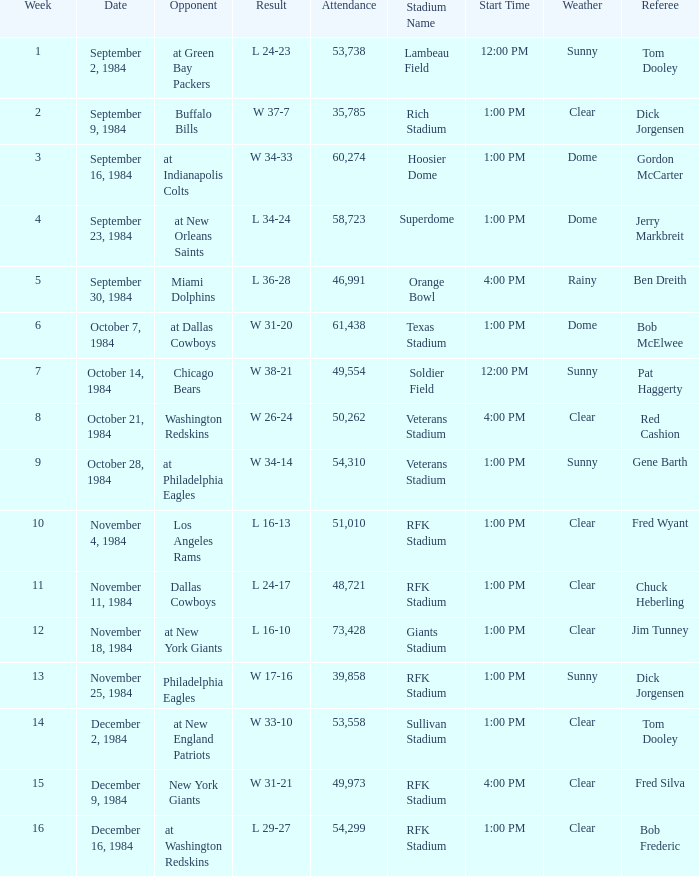What was the result in a week lower than 10 with an opponent of Chicago Bears? W 38-21. Would you be able to parse every entry in this table? {'header': ['Week', 'Date', 'Opponent', 'Result', 'Attendance', 'Stadium Name', 'Start Time', 'Weather', 'Referee'], 'rows': [['1', 'September 2, 1984', 'at Green Bay Packers', 'L 24-23', '53,738', 'Lambeau Field', '12:00 PM', 'Sunny', 'Tom Dooley'], ['2', 'September 9, 1984', 'Buffalo Bills', 'W 37-7', '35,785', 'Rich Stadium', '1:00 PM', 'Clear', 'Dick Jorgensen'], ['3', 'September 16, 1984', 'at Indianapolis Colts', 'W 34-33', '60,274', 'Hoosier Dome', '1:00 PM', 'Dome', 'Gordon McCarter'], ['4', 'September 23, 1984', 'at New Orleans Saints', 'L 34-24', '58,723', 'Superdome', '1:00 PM', 'Dome', 'Jerry Markbreit'], ['5', 'September 30, 1984', 'Miami Dolphins', 'L 36-28', '46,991', 'Orange Bowl', '4:00 PM', 'Rainy', 'Ben Dreith'], ['6', 'October 7, 1984', 'at Dallas Cowboys', 'W 31-20', '61,438', 'Texas Stadium', '1:00 PM', 'Dome', 'Bob McElwee'], ['7', 'October 14, 1984', 'Chicago Bears', 'W 38-21', '49,554', 'Soldier Field', '12:00 PM', 'Sunny', 'Pat Haggerty'], ['8', 'October 21, 1984', 'Washington Redskins', 'W 26-24', '50,262', 'Veterans Stadium', '4:00 PM', 'Clear', 'Red Cashion'], ['9', 'October 28, 1984', 'at Philadelphia Eagles', 'W 34-14', '54,310', 'Veterans Stadium', '1:00 PM', 'Sunny', 'Gene Barth'], ['10', 'November 4, 1984', 'Los Angeles Rams', 'L 16-13', '51,010', 'RFK Stadium', '1:00 PM', 'Clear', 'Fred Wyant'], ['11', 'November 11, 1984', 'Dallas Cowboys', 'L 24-17', '48,721', 'RFK Stadium', '1:00 PM', 'Clear', 'Chuck Heberling'], ['12', 'November 18, 1984', 'at New York Giants', 'L 16-10', '73,428', 'Giants Stadium', '1:00 PM', 'Clear', 'Jim Tunney'], ['13', 'November 25, 1984', 'Philadelphia Eagles', 'W 17-16', '39,858', 'RFK Stadium', '1:00 PM', 'Sunny', 'Dick Jorgensen'], ['14', 'December 2, 1984', 'at New England Patriots', 'W 33-10', '53,558', 'Sullivan Stadium', '1:00 PM', 'Clear', 'Tom Dooley'], ['15', 'December 9, 1984', 'New York Giants', 'W 31-21', '49,973', 'RFK Stadium', '4:00 PM', 'Clear', 'Fred Silva'], ['16', 'December 16, 1984', 'at Washington Redskins', 'L 29-27', '54,299', 'RFK Stadium', '1:00 PM', 'Clear', 'Bob Frederic']]} 